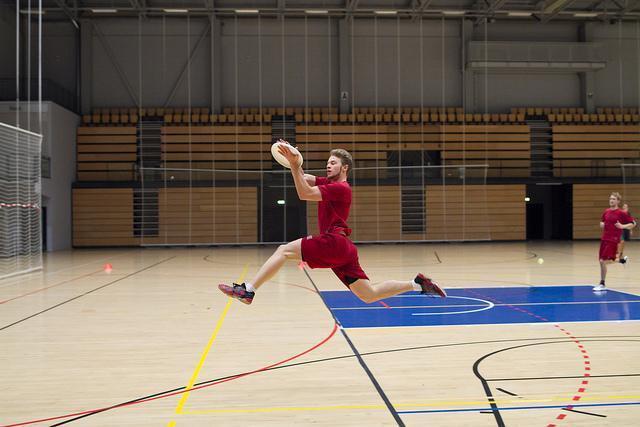How many buses are there?
Give a very brief answer. 0. 